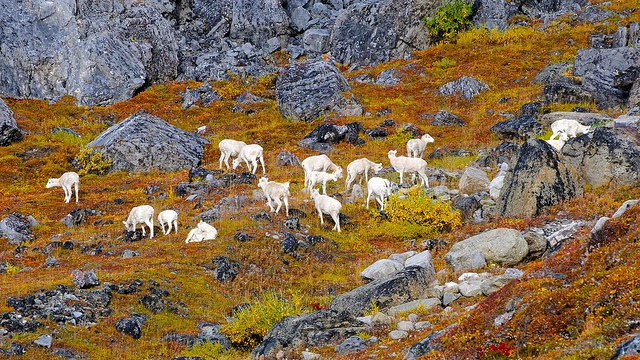Describe the objects in this image and their specific colors. I can see sheep in gray, lightgray, darkgray, tan, and olive tones, sheep in gray, lightgray, and darkgray tones, sheep in gray, lightgray, tan, and darkgray tones, sheep in gray, white, darkgray, and tan tones, and sheep in gray, lightgray, darkgray, and tan tones in this image. 